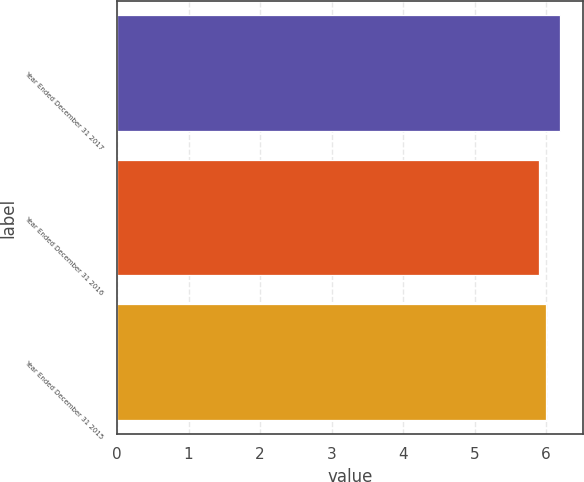<chart> <loc_0><loc_0><loc_500><loc_500><bar_chart><fcel>Year Ended December 31 2017<fcel>Year Ended December 31 2016<fcel>Year Ended December 31 2015<nl><fcel>6.2<fcel>5.9<fcel>6<nl></chart> 